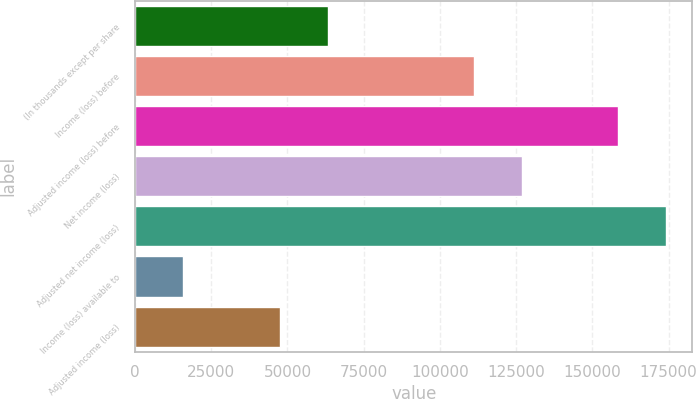Convert chart to OTSL. <chart><loc_0><loc_0><loc_500><loc_500><bar_chart><fcel>(In thousands except per share<fcel>Income (loss) before<fcel>Adjusted income (loss) before<fcel>Net income (loss)<fcel>Adjusted net income (loss)<fcel>Income (loss) available to<fcel>Adjusted income (loss)<nl><fcel>63321.7<fcel>111256<fcel>158302<fcel>127086<fcel>174132<fcel>15831.6<fcel>47491.7<nl></chart> 